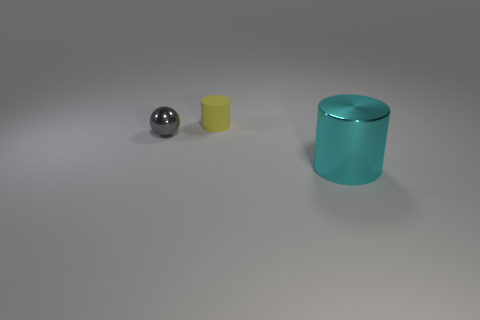What shape is the other gray object that is the same material as the large thing?
Your answer should be very brief. Sphere. There is a metallic object that is in front of the shiny thing that is behind the thing that is in front of the gray metallic ball; what shape is it?
Ensure brevity in your answer.  Cylinder. Is the number of small brown cubes greater than the number of big metal objects?
Your answer should be very brief. No. There is a small yellow object that is the same shape as the big thing; what is its material?
Your response must be concise. Rubber. Does the cyan object have the same material as the small ball?
Provide a short and direct response. Yes. Are there more big metallic cylinders on the right side of the yellow cylinder than cyan metal cylinders?
Your answer should be compact. No. What is the material of the cylinder that is in front of the cylinder that is on the left side of the large cyan shiny cylinder in front of the tiny matte object?
Offer a very short reply. Metal. What number of objects are either purple matte spheres or cylinders behind the big cyan cylinder?
Provide a short and direct response. 1. Is the number of cyan metallic cylinders behind the cyan metal thing greater than the number of yellow matte cylinders that are in front of the rubber cylinder?
Make the answer very short. No. Is there any other thing of the same color as the tiny cylinder?
Provide a short and direct response. No. 